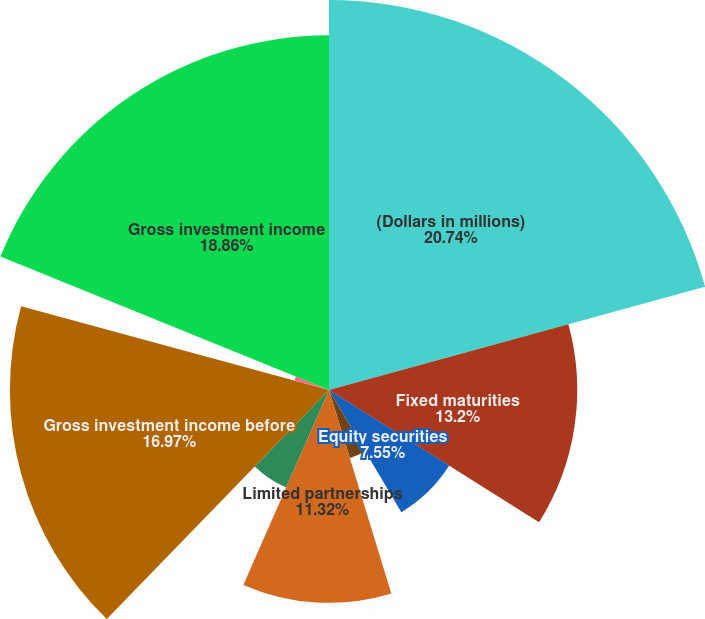<chart> <loc_0><loc_0><loc_500><loc_500><pie_chart><fcel>(Dollars in millions)<fcel>Fixed maturities<fcel>Equity securities<fcel>Short-term investments and<fcel>Limited partnerships<fcel>Other<fcel>Gross investment income before<fcel>Funds held interest income<fcel>Future policy benefit reserve<fcel>Gross investment income<nl><fcel>20.74%<fcel>13.2%<fcel>7.55%<fcel>3.78%<fcel>11.32%<fcel>5.67%<fcel>16.97%<fcel>1.9%<fcel>0.01%<fcel>18.86%<nl></chart> 